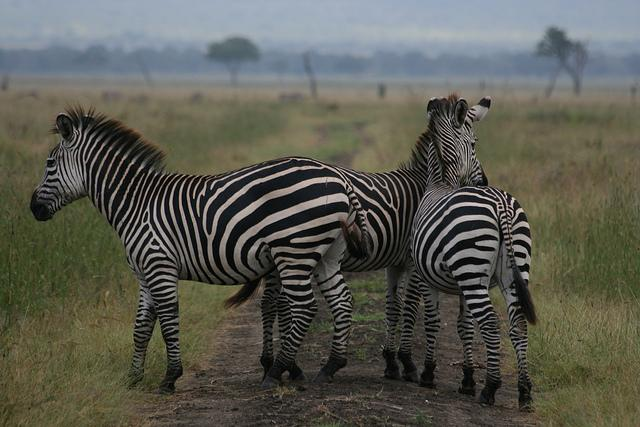How many zebras are standing in the way of the path? Please explain your reasoning. three. The zebras are clearly visible and countable based on their distinct outlines. 